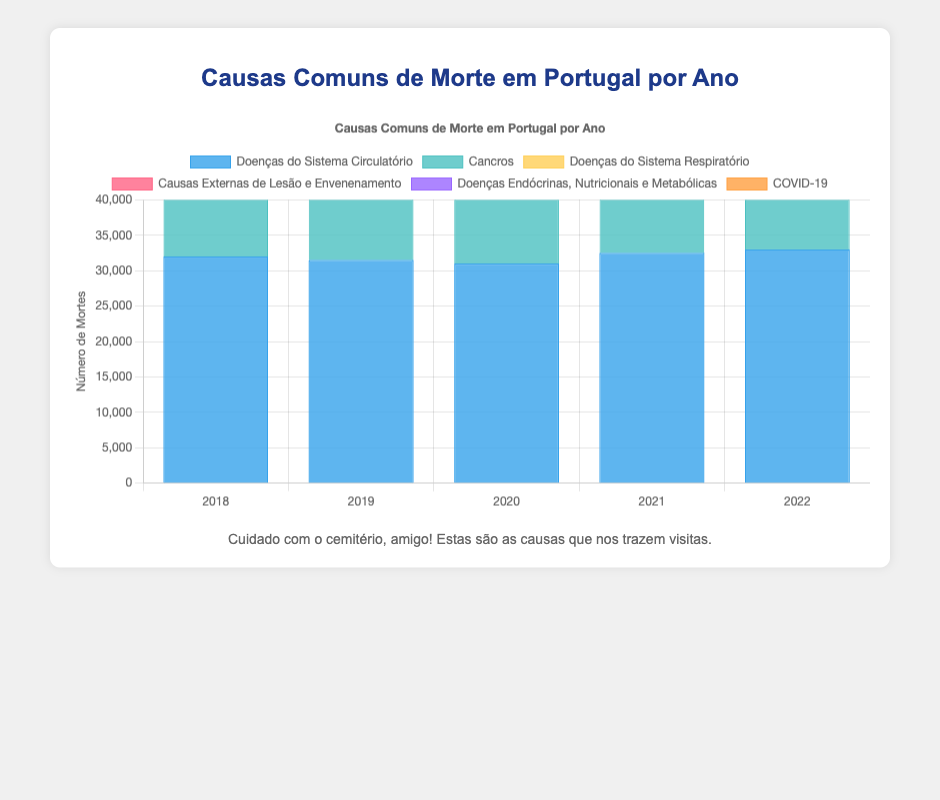What is the most common cause of death in Portugal in 2018? Look at the tallest bar for the year 2018 in the bar chart. The tallest bar represents "Doenças do Sistema Circulatório" with 32,000 deaths.
Answer: Doenças do Sistema Circulatório Which year had the highest number of deaths caused by cancers? Find the year with the tallest bar in the section for "Cancros." In 2022, the bar for "Cancros" reaches 33,000 deaths.
Answer: 2022 How did the number of deaths from COVID-19 change between 2020 and 2021? Compare the heights of the bars for "COVID-19" between 2020 and 2021. The number of deaths increased from 3,000 in 2020 to 5,000 in 2021, a difference of 2,000.
Answer: Increased Which cause of death had the smallest increase between 2018 and 2022? Calculate the difference for each cause between 2018 and 2022: "Doenças do Sistema Circulatório" (33,000 - 32,000 = 1,000), "Cancros" (33,000 - 29,000 = 4,000), "Doenças do Sistema Respiratório" (16,000 - 15,000 = 1,000), "Causas Externas de Lesão e Envenenamento" (8,700 - 8,000 = 700), and "Doenças Endócrinas, Nutricionais e Metabólicas" (6,600 - 6,000 = 600). The smallest increase is for "Doenças Endócrinas, Nutricionais e Metabólicas" with 600.
Answer: Doenças Endócrinas, Nutricionais e Metabólicas How do the total deaths from "Doenças do Sistema Circulatório" compare across all years? Observe the heights of the blue bars for each year. The values are relatively close, ranging from 31,000 to 33,000, showing no drastic fluctuations but a slight increase over time.
Answer: Slight increase What is the biggest difference in deaths for "Doenças do Sistema Respiratório" between any two consecutive years? Calculate the year-to-year differences: between 2018 and 2019 (16,000 - 15,000 = 1,000), between 2019 and 2020 (17,000 - 16,000 = 1,000), between 2020 and 2021 (16,500 - 17,000 = -500), and between 2021 and 2022 (16,000 - 16,500 = -500). The biggest positive difference is 1,000 between 2019 and 2020.
Answer: 1,000 Between which two years did the number of deaths from "Causas Externas de Lesão e Envenenamento" decrease? Compare the heights year by year for "Causas Externas de Lesão e Envenenamento": from 2018 to 2019 (8,000 to 8,500), 2019 to 2020 (8,500 to 9,000), 2020 to 2021 (9,000 to 8,800), and 2021 to 2022 (8,800 to 8,700). The decrease was between 2020 and 2021, and between 2021 and 2022.
Answer: 2020-2021, 2021-2022 Which category consistently had the lowest number of deaths over the years 2018-2022? Look at the height of the bars across all categories for each year. "Doenças Endócrinas, Nutricionais e Metabólicas" consistently has the shortest bars.
Answer: Doenças Endócrinas, Nutricionais e Metabólicas 